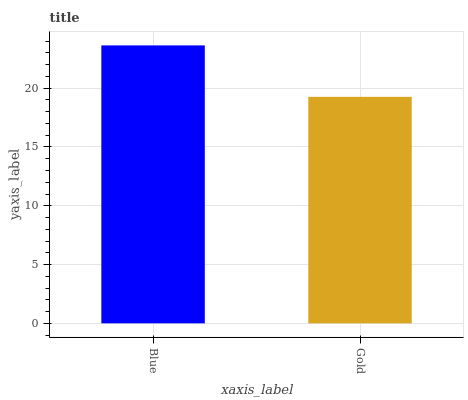Is Gold the minimum?
Answer yes or no. Yes. Is Blue the maximum?
Answer yes or no. Yes. Is Gold the maximum?
Answer yes or no. No. Is Blue greater than Gold?
Answer yes or no. Yes. Is Gold less than Blue?
Answer yes or no. Yes. Is Gold greater than Blue?
Answer yes or no. No. Is Blue less than Gold?
Answer yes or no. No. Is Blue the high median?
Answer yes or no. Yes. Is Gold the low median?
Answer yes or no. Yes. Is Gold the high median?
Answer yes or no. No. Is Blue the low median?
Answer yes or no. No. 